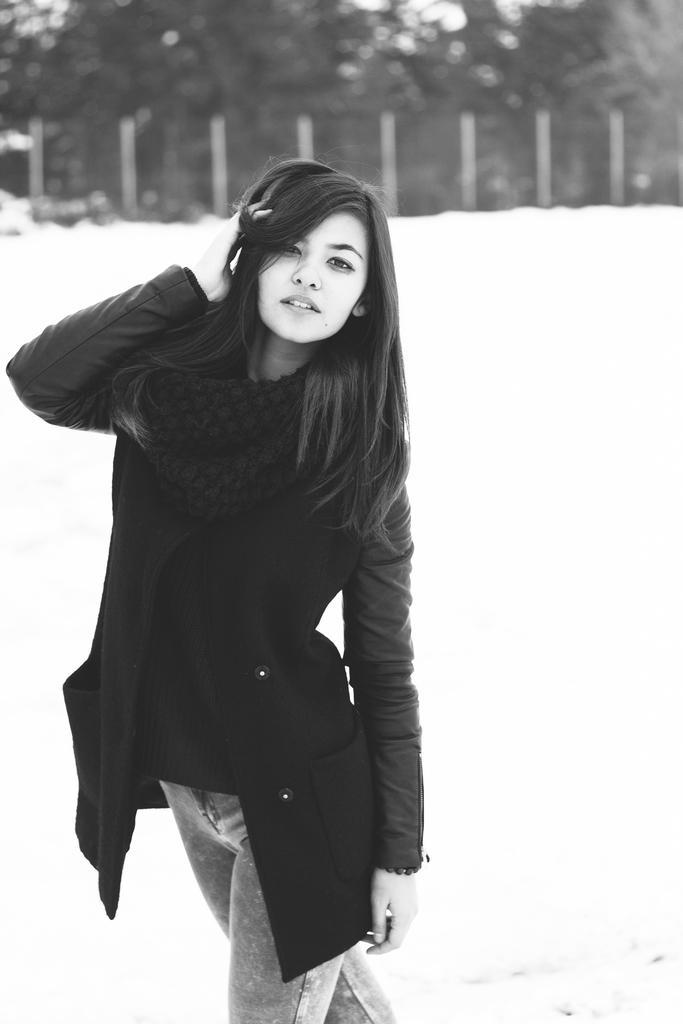Can you describe this image briefly? In this black and white picture there is a woman wearing a jacket and scarf. She is standing on the land. Top of image there is a fence. Behind it there are few trees. 